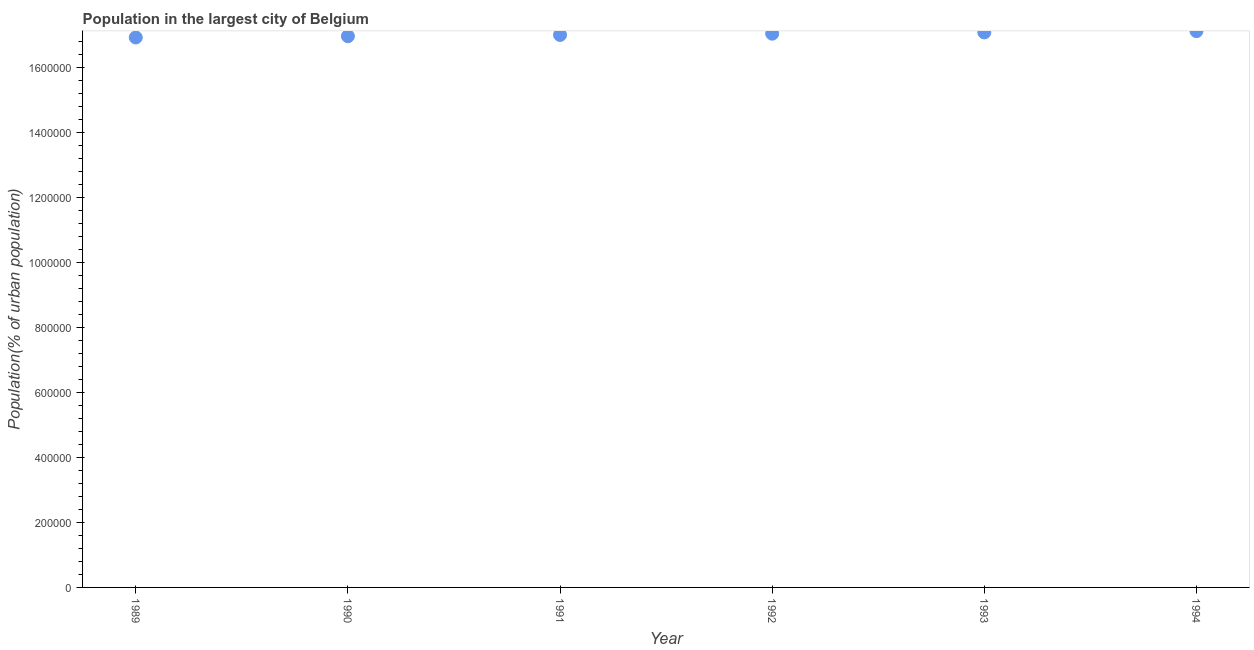What is the population in largest city in 1990?
Offer a terse response. 1.70e+06. Across all years, what is the maximum population in largest city?
Give a very brief answer. 1.71e+06. Across all years, what is the minimum population in largest city?
Ensure brevity in your answer.  1.69e+06. In which year was the population in largest city maximum?
Your answer should be very brief. 1994. In which year was the population in largest city minimum?
Your response must be concise. 1989. What is the sum of the population in largest city?
Offer a terse response. 1.02e+07. What is the difference between the population in largest city in 1993 and 1994?
Keep it short and to the point. -3910. What is the average population in largest city per year?
Ensure brevity in your answer.  1.70e+06. What is the median population in largest city?
Provide a succinct answer. 1.70e+06. In how many years, is the population in largest city greater than 1200000 %?
Provide a short and direct response. 6. What is the ratio of the population in largest city in 1993 to that in 1994?
Your response must be concise. 1. Is the population in largest city in 1989 less than that in 1994?
Your answer should be compact. Yes. Is the difference between the population in largest city in 1990 and 1991 greater than the difference between any two years?
Make the answer very short. No. What is the difference between the highest and the second highest population in largest city?
Offer a terse response. 3910. What is the difference between the highest and the lowest population in largest city?
Your answer should be very brief. 1.95e+04. Does the population in largest city monotonically increase over the years?
Keep it short and to the point. Yes. How many dotlines are there?
Offer a very short reply. 1. How many years are there in the graph?
Your answer should be very brief. 6. Does the graph contain any zero values?
Your answer should be very brief. No. What is the title of the graph?
Keep it short and to the point. Population in the largest city of Belgium. What is the label or title of the Y-axis?
Your answer should be compact. Population(% of urban population). What is the Population(% of urban population) in 1989?
Your answer should be very brief. 1.69e+06. What is the Population(% of urban population) in 1990?
Ensure brevity in your answer.  1.70e+06. What is the Population(% of urban population) in 1991?
Make the answer very short. 1.70e+06. What is the Population(% of urban population) in 1992?
Provide a succinct answer. 1.70e+06. What is the Population(% of urban population) in 1993?
Provide a short and direct response. 1.71e+06. What is the Population(% of urban population) in 1994?
Ensure brevity in your answer.  1.71e+06. What is the difference between the Population(% of urban population) in 1989 and 1990?
Keep it short and to the point. -3874. What is the difference between the Population(% of urban population) in 1989 and 1991?
Offer a terse response. -7758. What is the difference between the Population(% of urban population) in 1989 and 1992?
Your answer should be compact. -1.17e+04. What is the difference between the Population(% of urban population) in 1989 and 1993?
Your response must be concise. -1.56e+04. What is the difference between the Population(% of urban population) in 1989 and 1994?
Ensure brevity in your answer.  -1.95e+04. What is the difference between the Population(% of urban population) in 1990 and 1991?
Offer a very short reply. -3884. What is the difference between the Population(% of urban population) in 1990 and 1992?
Give a very brief answer. -7781. What is the difference between the Population(% of urban population) in 1990 and 1993?
Provide a succinct answer. -1.17e+04. What is the difference between the Population(% of urban population) in 1990 and 1994?
Keep it short and to the point. -1.56e+04. What is the difference between the Population(% of urban population) in 1991 and 1992?
Offer a terse response. -3897. What is the difference between the Population(% of urban population) in 1991 and 1993?
Your answer should be very brief. -7793. What is the difference between the Population(% of urban population) in 1991 and 1994?
Offer a very short reply. -1.17e+04. What is the difference between the Population(% of urban population) in 1992 and 1993?
Your answer should be compact. -3896. What is the difference between the Population(% of urban population) in 1992 and 1994?
Your answer should be compact. -7806. What is the difference between the Population(% of urban population) in 1993 and 1994?
Your answer should be very brief. -3910. What is the ratio of the Population(% of urban population) in 1989 to that in 1991?
Provide a succinct answer. 0.99. What is the ratio of the Population(% of urban population) in 1990 to that in 1991?
Offer a terse response. 1. What is the ratio of the Population(% of urban population) in 1990 to that in 1993?
Provide a short and direct response. 0.99. What is the ratio of the Population(% of urban population) in 1991 to that in 1993?
Give a very brief answer. 0.99. What is the ratio of the Population(% of urban population) in 1991 to that in 1994?
Your answer should be compact. 0.99. What is the ratio of the Population(% of urban population) in 1992 to that in 1993?
Offer a terse response. 1. What is the ratio of the Population(% of urban population) in 1992 to that in 1994?
Provide a short and direct response. 0.99. What is the ratio of the Population(% of urban population) in 1993 to that in 1994?
Offer a very short reply. 1. 